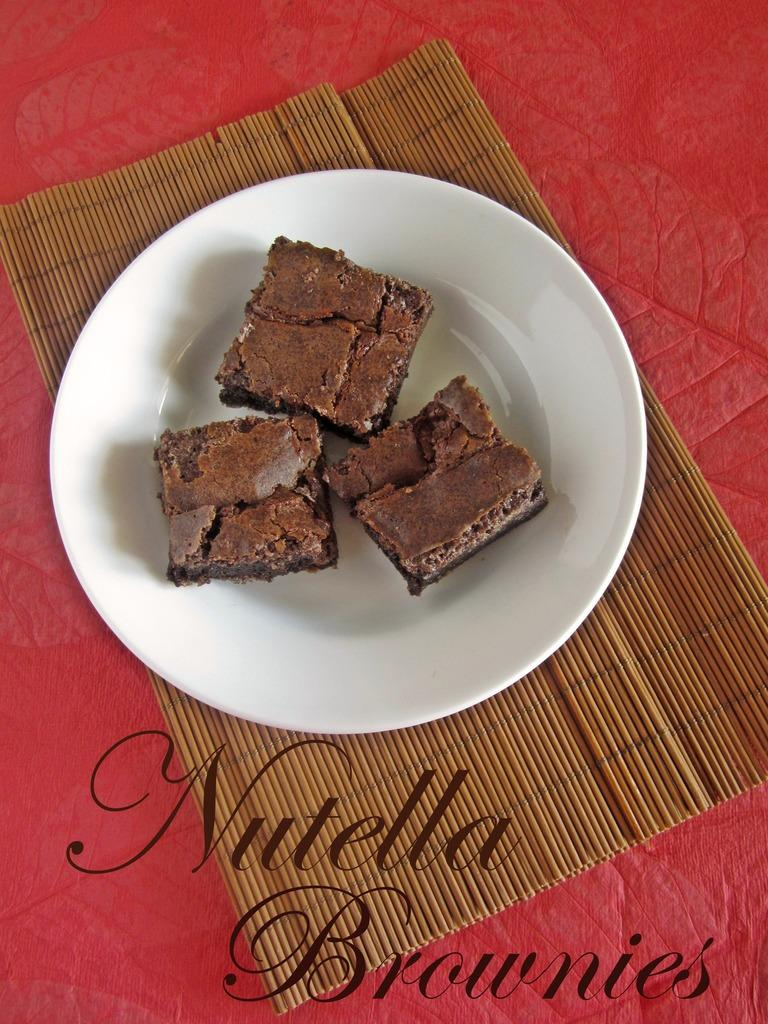What is on the plate that is visible in the image? The plate contains three cake pieces in the image. What is the plate placed on? The plate is placed on a wooden mat. What color is the background of the image? The background of the image is red. What can be found at the bottom of the image? There is text written at the bottom of the image. How many rabbits are hopping around the cake pieces in the image? There are no rabbits present in the image; it only features a plate with cake pieces, a wooden mat, and text at the bottom. 